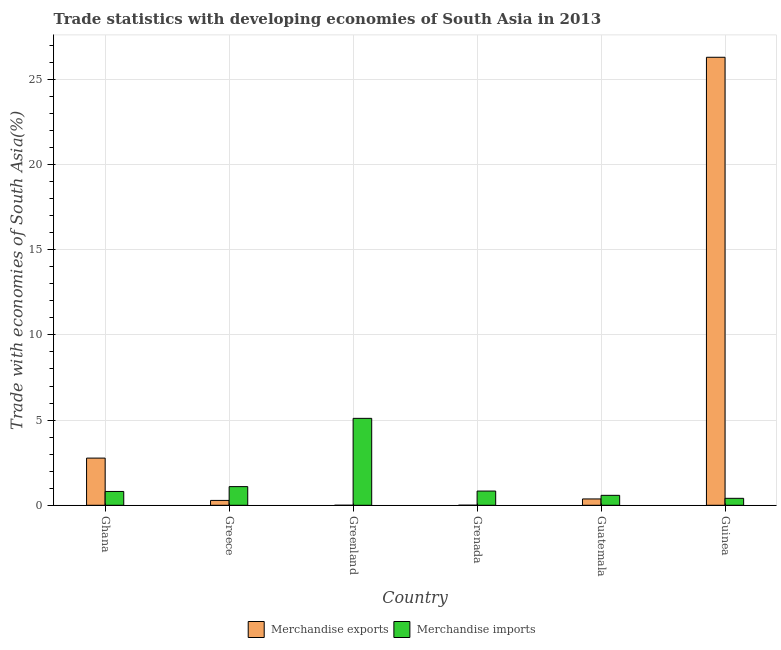How many different coloured bars are there?
Provide a short and direct response. 2. How many groups of bars are there?
Your answer should be compact. 6. Are the number of bars per tick equal to the number of legend labels?
Your response must be concise. Yes. Are the number of bars on each tick of the X-axis equal?
Your answer should be compact. Yes. How many bars are there on the 1st tick from the left?
Provide a short and direct response. 2. What is the label of the 4th group of bars from the left?
Offer a terse response. Grenada. In how many cases, is the number of bars for a given country not equal to the number of legend labels?
Offer a terse response. 0. What is the merchandise exports in Greenland?
Offer a terse response. 2.16204053432962e-5. Across all countries, what is the maximum merchandise exports?
Your answer should be very brief. 26.29. Across all countries, what is the minimum merchandise imports?
Offer a terse response. 0.41. In which country was the merchandise imports maximum?
Provide a succinct answer. Greenland. In which country was the merchandise exports minimum?
Offer a very short reply. Greenland. What is the total merchandise exports in the graph?
Your answer should be very brief. 29.72. What is the difference between the merchandise exports in Ghana and that in Greenland?
Ensure brevity in your answer.  2.77. What is the difference between the merchandise exports in Grenada and the merchandise imports in Guinea?
Provide a short and direct response. -0.4. What is the average merchandise exports per country?
Offer a very short reply. 4.95. What is the difference between the merchandise imports and merchandise exports in Greenland?
Ensure brevity in your answer.  5.1. In how many countries, is the merchandise imports greater than 3 %?
Offer a very short reply. 1. What is the ratio of the merchandise imports in Greece to that in Guinea?
Offer a very short reply. 2.68. What is the difference between the highest and the second highest merchandise imports?
Your answer should be compact. 4.01. What is the difference between the highest and the lowest merchandise imports?
Your answer should be very brief. 4.69. In how many countries, is the merchandise imports greater than the average merchandise imports taken over all countries?
Your response must be concise. 1. What does the 2nd bar from the right in Guatemala represents?
Keep it short and to the point. Merchandise exports. How many countries are there in the graph?
Keep it short and to the point. 6. What is the difference between two consecutive major ticks on the Y-axis?
Offer a terse response. 5. Does the graph contain grids?
Give a very brief answer. Yes. Where does the legend appear in the graph?
Your answer should be compact. Bottom center. How are the legend labels stacked?
Keep it short and to the point. Horizontal. What is the title of the graph?
Keep it short and to the point. Trade statistics with developing economies of South Asia in 2013. Does "Under-5(female)" appear as one of the legend labels in the graph?
Provide a short and direct response. No. What is the label or title of the X-axis?
Give a very brief answer. Country. What is the label or title of the Y-axis?
Give a very brief answer. Trade with economies of South Asia(%). What is the Trade with economies of South Asia(%) of Merchandise exports in Ghana?
Provide a short and direct response. 2.77. What is the Trade with economies of South Asia(%) in Merchandise imports in Ghana?
Provide a short and direct response. 0.81. What is the Trade with economies of South Asia(%) of Merchandise exports in Greece?
Keep it short and to the point. 0.29. What is the Trade with economies of South Asia(%) of Merchandise imports in Greece?
Ensure brevity in your answer.  1.09. What is the Trade with economies of South Asia(%) in Merchandise exports in Greenland?
Offer a terse response. 2.16204053432962e-5. What is the Trade with economies of South Asia(%) of Merchandise imports in Greenland?
Make the answer very short. 5.1. What is the Trade with economies of South Asia(%) of Merchandise exports in Grenada?
Provide a succinct answer. 0. What is the Trade with economies of South Asia(%) in Merchandise imports in Grenada?
Provide a short and direct response. 0.83. What is the Trade with economies of South Asia(%) of Merchandise exports in Guatemala?
Your answer should be compact. 0.37. What is the Trade with economies of South Asia(%) of Merchandise imports in Guatemala?
Offer a very short reply. 0.58. What is the Trade with economies of South Asia(%) in Merchandise exports in Guinea?
Provide a short and direct response. 26.29. What is the Trade with economies of South Asia(%) in Merchandise imports in Guinea?
Your answer should be very brief. 0.41. Across all countries, what is the maximum Trade with economies of South Asia(%) in Merchandise exports?
Your answer should be compact. 26.29. Across all countries, what is the maximum Trade with economies of South Asia(%) in Merchandise imports?
Provide a short and direct response. 5.1. Across all countries, what is the minimum Trade with economies of South Asia(%) of Merchandise exports?
Your answer should be compact. 2.16204053432962e-5. Across all countries, what is the minimum Trade with economies of South Asia(%) in Merchandise imports?
Offer a terse response. 0.41. What is the total Trade with economies of South Asia(%) of Merchandise exports in the graph?
Provide a succinct answer. 29.72. What is the total Trade with economies of South Asia(%) in Merchandise imports in the graph?
Keep it short and to the point. 8.83. What is the difference between the Trade with economies of South Asia(%) of Merchandise exports in Ghana and that in Greece?
Offer a terse response. 2.48. What is the difference between the Trade with economies of South Asia(%) in Merchandise imports in Ghana and that in Greece?
Your answer should be compact. -0.28. What is the difference between the Trade with economies of South Asia(%) of Merchandise exports in Ghana and that in Greenland?
Offer a terse response. 2.77. What is the difference between the Trade with economies of South Asia(%) of Merchandise imports in Ghana and that in Greenland?
Give a very brief answer. -4.29. What is the difference between the Trade with economies of South Asia(%) in Merchandise exports in Ghana and that in Grenada?
Keep it short and to the point. 2.76. What is the difference between the Trade with economies of South Asia(%) in Merchandise imports in Ghana and that in Grenada?
Ensure brevity in your answer.  -0.02. What is the difference between the Trade with economies of South Asia(%) in Merchandise exports in Ghana and that in Guatemala?
Provide a short and direct response. 2.4. What is the difference between the Trade with economies of South Asia(%) of Merchandise imports in Ghana and that in Guatemala?
Ensure brevity in your answer.  0.23. What is the difference between the Trade with economies of South Asia(%) of Merchandise exports in Ghana and that in Guinea?
Keep it short and to the point. -23.53. What is the difference between the Trade with economies of South Asia(%) in Merchandise imports in Ghana and that in Guinea?
Your response must be concise. 0.4. What is the difference between the Trade with economies of South Asia(%) in Merchandise exports in Greece and that in Greenland?
Offer a very short reply. 0.29. What is the difference between the Trade with economies of South Asia(%) in Merchandise imports in Greece and that in Greenland?
Give a very brief answer. -4.01. What is the difference between the Trade with economies of South Asia(%) of Merchandise exports in Greece and that in Grenada?
Provide a short and direct response. 0.28. What is the difference between the Trade with economies of South Asia(%) in Merchandise imports in Greece and that in Grenada?
Offer a very short reply. 0.26. What is the difference between the Trade with economies of South Asia(%) in Merchandise exports in Greece and that in Guatemala?
Your response must be concise. -0.09. What is the difference between the Trade with economies of South Asia(%) in Merchandise imports in Greece and that in Guatemala?
Make the answer very short. 0.51. What is the difference between the Trade with economies of South Asia(%) in Merchandise exports in Greece and that in Guinea?
Give a very brief answer. -26.01. What is the difference between the Trade with economies of South Asia(%) in Merchandise imports in Greece and that in Guinea?
Your response must be concise. 0.69. What is the difference between the Trade with economies of South Asia(%) of Merchandise exports in Greenland and that in Grenada?
Offer a very short reply. -0. What is the difference between the Trade with economies of South Asia(%) of Merchandise imports in Greenland and that in Grenada?
Offer a very short reply. 4.27. What is the difference between the Trade with economies of South Asia(%) in Merchandise exports in Greenland and that in Guatemala?
Your answer should be compact. -0.37. What is the difference between the Trade with economies of South Asia(%) in Merchandise imports in Greenland and that in Guatemala?
Keep it short and to the point. 4.52. What is the difference between the Trade with economies of South Asia(%) in Merchandise exports in Greenland and that in Guinea?
Your answer should be very brief. -26.29. What is the difference between the Trade with economies of South Asia(%) of Merchandise imports in Greenland and that in Guinea?
Make the answer very short. 4.69. What is the difference between the Trade with economies of South Asia(%) of Merchandise exports in Grenada and that in Guatemala?
Your response must be concise. -0.37. What is the difference between the Trade with economies of South Asia(%) in Merchandise imports in Grenada and that in Guatemala?
Provide a succinct answer. 0.25. What is the difference between the Trade with economies of South Asia(%) in Merchandise exports in Grenada and that in Guinea?
Your answer should be compact. -26.29. What is the difference between the Trade with economies of South Asia(%) of Merchandise imports in Grenada and that in Guinea?
Make the answer very short. 0.43. What is the difference between the Trade with economies of South Asia(%) in Merchandise exports in Guatemala and that in Guinea?
Offer a very short reply. -25.92. What is the difference between the Trade with economies of South Asia(%) of Merchandise imports in Guatemala and that in Guinea?
Provide a short and direct response. 0.18. What is the difference between the Trade with economies of South Asia(%) in Merchandise exports in Ghana and the Trade with economies of South Asia(%) in Merchandise imports in Greece?
Make the answer very short. 1.67. What is the difference between the Trade with economies of South Asia(%) of Merchandise exports in Ghana and the Trade with economies of South Asia(%) of Merchandise imports in Greenland?
Provide a succinct answer. -2.33. What is the difference between the Trade with economies of South Asia(%) of Merchandise exports in Ghana and the Trade with economies of South Asia(%) of Merchandise imports in Grenada?
Your response must be concise. 1.93. What is the difference between the Trade with economies of South Asia(%) of Merchandise exports in Ghana and the Trade with economies of South Asia(%) of Merchandise imports in Guatemala?
Offer a very short reply. 2.18. What is the difference between the Trade with economies of South Asia(%) in Merchandise exports in Ghana and the Trade with economies of South Asia(%) in Merchandise imports in Guinea?
Provide a succinct answer. 2.36. What is the difference between the Trade with economies of South Asia(%) in Merchandise exports in Greece and the Trade with economies of South Asia(%) in Merchandise imports in Greenland?
Offer a terse response. -4.82. What is the difference between the Trade with economies of South Asia(%) of Merchandise exports in Greece and the Trade with economies of South Asia(%) of Merchandise imports in Grenada?
Offer a terse response. -0.55. What is the difference between the Trade with economies of South Asia(%) of Merchandise exports in Greece and the Trade with economies of South Asia(%) of Merchandise imports in Guatemala?
Keep it short and to the point. -0.3. What is the difference between the Trade with economies of South Asia(%) in Merchandise exports in Greece and the Trade with economies of South Asia(%) in Merchandise imports in Guinea?
Ensure brevity in your answer.  -0.12. What is the difference between the Trade with economies of South Asia(%) of Merchandise exports in Greenland and the Trade with economies of South Asia(%) of Merchandise imports in Grenada?
Provide a short and direct response. -0.83. What is the difference between the Trade with economies of South Asia(%) in Merchandise exports in Greenland and the Trade with economies of South Asia(%) in Merchandise imports in Guatemala?
Provide a short and direct response. -0.58. What is the difference between the Trade with economies of South Asia(%) of Merchandise exports in Greenland and the Trade with economies of South Asia(%) of Merchandise imports in Guinea?
Give a very brief answer. -0.41. What is the difference between the Trade with economies of South Asia(%) in Merchandise exports in Grenada and the Trade with economies of South Asia(%) in Merchandise imports in Guatemala?
Give a very brief answer. -0.58. What is the difference between the Trade with economies of South Asia(%) of Merchandise exports in Grenada and the Trade with economies of South Asia(%) of Merchandise imports in Guinea?
Offer a terse response. -0.4. What is the difference between the Trade with economies of South Asia(%) of Merchandise exports in Guatemala and the Trade with economies of South Asia(%) of Merchandise imports in Guinea?
Ensure brevity in your answer.  -0.04. What is the average Trade with economies of South Asia(%) in Merchandise exports per country?
Your response must be concise. 4.95. What is the average Trade with economies of South Asia(%) of Merchandise imports per country?
Make the answer very short. 1.47. What is the difference between the Trade with economies of South Asia(%) in Merchandise exports and Trade with economies of South Asia(%) in Merchandise imports in Ghana?
Offer a very short reply. 1.96. What is the difference between the Trade with economies of South Asia(%) in Merchandise exports and Trade with economies of South Asia(%) in Merchandise imports in Greece?
Your answer should be very brief. -0.81. What is the difference between the Trade with economies of South Asia(%) of Merchandise exports and Trade with economies of South Asia(%) of Merchandise imports in Greenland?
Provide a succinct answer. -5.1. What is the difference between the Trade with economies of South Asia(%) in Merchandise exports and Trade with economies of South Asia(%) in Merchandise imports in Grenada?
Give a very brief answer. -0.83. What is the difference between the Trade with economies of South Asia(%) of Merchandise exports and Trade with economies of South Asia(%) of Merchandise imports in Guatemala?
Offer a terse response. -0.21. What is the difference between the Trade with economies of South Asia(%) of Merchandise exports and Trade with economies of South Asia(%) of Merchandise imports in Guinea?
Your answer should be compact. 25.89. What is the ratio of the Trade with economies of South Asia(%) in Merchandise exports in Ghana to that in Greece?
Your answer should be very brief. 9.7. What is the ratio of the Trade with economies of South Asia(%) in Merchandise imports in Ghana to that in Greece?
Your response must be concise. 0.74. What is the ratio of the Trade with economies of South Asia(%) of Merchandise exports in Ghana to that in Greenland?
Give a very brief answer. 1.28e+05. What is the ratio of the Trade with economies of South Asia(%) of Merchandise imports in Ghana to that in Greenland?
Keep it short and to the point. 0.16. What is the ratio of the Trade with economies of South Asia(%) of Merchandise exports in Ghana to that in Grenada?
Your response must be concise. 758.55. What is the ratio of the Trade with economies of South Asia(%) in Merchandise imports in Ghana to that in Grenada?
Your answer should be very brief. 0.97. What is the ratio of the Trade with economies of South Asia(%) in Merchandise exports in Ghana to that in Guatemala?
Keep it short and to the point. 7.45. What is the ratio of the Trade with economies of South Asia(%) of Merchandise imports in Ghana to that in Guatemala?
Offer a very short reply. 1.39. What is the ratio of the Trade with economies of South Asia(%) in Merchandise exports in Ghana to that in Guinea?
Make the answer very short. 0.11. What is the ratio of the Trade with economies of South Asia(%) in Merchandise imports in Ghana to that in Guinea?
Keep it short and to the point. 1.99. What is the ratio of the Trade with economies of South Asia(%) of Merchandise exports in Greece to that in Greenland?
Provide a short and direct response. 1.32e+04. What is the ratio of the Trade with economies of South Asia(%) in Merchandise imports in Greece to that in Greenland?
Offer a terse response. 0.21. What is the ratio of the Trade with economies of South Asia(%) in Merchandise exports in Greece to that in Grenada?
Your response must be concise. 78.17. What is the ratio of the Trade with economies of South Asia(%) of Merchandise imports in Greece to that in Grenada?
Offer a very short reply. 1.31. What is the ratio of the Trade with economies of South Asia(%) of Merchandise exports in Greece to that in Guatemala?
Provide a succinct answer. 0.77. What is the ratio of the Trade with economies of South Asia(%) in Merchandise imports in Greece to that in Guatemala?
Your response must be concise. 1.88. What is the ratio of the Trade with economies of South Asia(%) of Merchandise exports in Greece to that in Guinea?
Provide a short and direct response. 0.01. What is the ratio of the Trade with economies of South Asia(%) of Merchandise imports in Greece to that in Guinea?
Ensure brevity in your answer.  2.68. What is the ratio of the Trade with economies of South Asia(%) in Merchandise exports in Greenland to that in Grenada?
Offer a terse response. 0.01. What is the ratio of the Trade with economies of South Asia(%) of Merchandise imports in Greenland to that in Grenada?
Offer a terse response. 6.11. What is the ratio of the Trade with economies of South Asia(%) of Merchandise imports in Greenland to that in Guatemala?
Keep it short and to the point. 8.74. What is the ratio of the Trade with economies of South Asia(%) in Merchandise exports in Greenland to that in Guinea?
Keep it short and to the point. 0. What is the ratio of the Trade with economies of South Asia(%) of Merchandise imports in Greenland to that in Guinea?
Your response must be concise. 12.51. What is the ratio of the Trade with economies of South Asia(%) of Merchandise exports in Grenada to that in Guatemala?
Provide a short and direct response. 0.01. What is the ratio of the Trade with economies of South Asia(%) in Merchandise imports in Grenada to that in Guatemala?
Provide a succinct answer. 1.43. What is the ratio of the Trade with economies of South Asia(%) of Merchandise imports in Grenada to that in Guinea?
Offer a terse response. 2.05. What is the ratio of the Trade with economies of South Asia(%) in Merchandise exports in Guatemala to that in Guinea?
Keep it short and to the point. 0.01. What is the ratio of the Trade with economies of South Asia(%) of Merchandise imports in Guatemala to that in Guinea?
Make the answer very short. 1.43. What is the difference between the highest and the second highest Trade with economies of South Asia(%) in Merchandise exports?
Your response must be concise. 23.53. What is the difference between the highest and the second highest Trade with economies of South Asia(%) in Merchandise imports?
Ensure brevity in your answer.  4.01. What is the difference between the highest and the lowest Trade with economies of South Asia(%) of Merchandise exports?
Ensure brevity in your answer.  26.29. What is the difference between the highest and the lowest Trade with economies of South Asia(%) of Merchandise imports?
Your answer should be very brief. 4.69. 